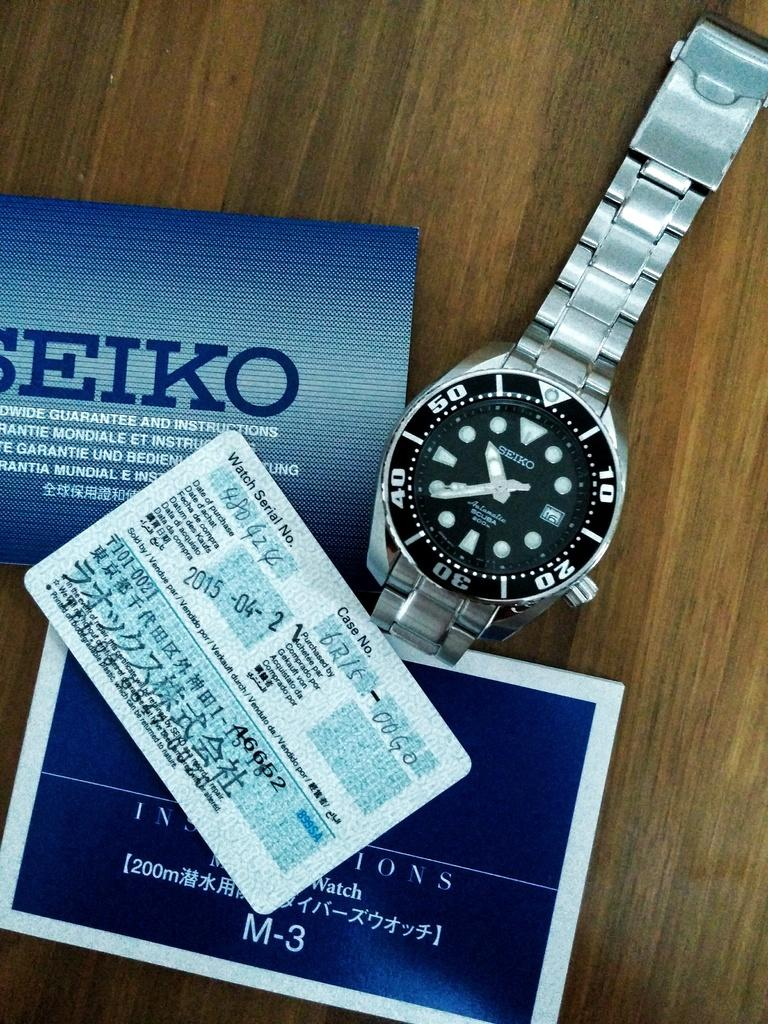Provide a one-sentence caption for the provided image. A Seiko watch with a black face sits next to a box and certificate. 